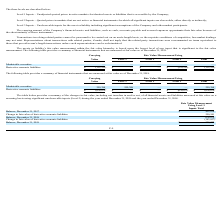According to Protagenic Therapeutics's financial document, What does a Level 1 input refer to? Unadjusted quoted prices in active markets for identical assets or liabilities that is accessible by the Company. The document states: "Level 1 Inputs – Unadjusted quoted prices in active markets for identical assets or liabilities that is accessible by the Company; Level 2 Inputs – Qu..." Also, What does a Level 2 input refer to? Quoted prices in markets that are not active or financial instruments for which all significant inputs are observable, either directly or indirectly. The document states: "at is accessible by the Company; Level 2 Inputs – Quoted prices in markets that are not active or financial instruments for which all significant inpu..." Also, What does a Level 3 input refer to? Unobservable inputs for the asset or liability including significant assumptions of the Company and other market participants. The document states: ", either directly or indirectly; Level 3 Inputs – Unobservable inputs for the asset or liability including significant assumptions of the Company and ..." Also, can you calculate: What is the difference in Level 1 and Level 2 marketable securities? I cannot find a specific answer to this question in the financial document. Also, can you calculate: What is the total Level 3 marketable securities and derivative warrants liabilities?  Based on the calculation: 332,222 + 0 , the result is 332222. This is based on the information: "Derivative warrants liabilities $ (332,222 ) $ — $ — $ (332,222 ) $ (332,222 ) at are measured at fair value as of December 31, 2019...." The key data points involved are: 0, 332,222. Also, can you calculate: What percentage of the total financial instruments are marketable securities? I cannot find a specific answer to this question in the financial document. 